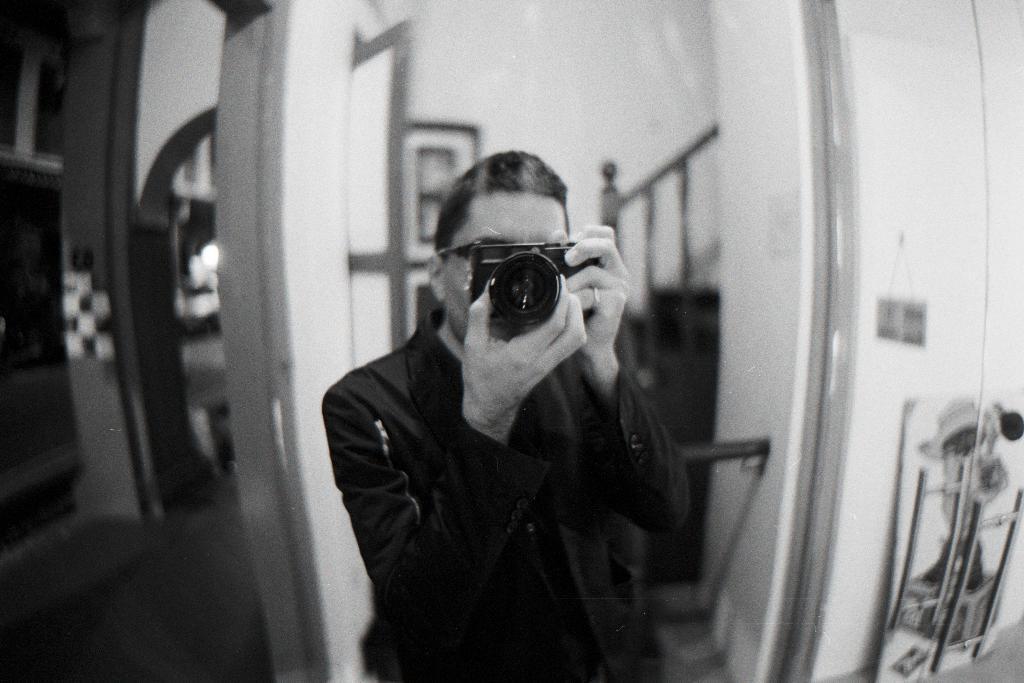Can you describe this image briefly? In this picture there is a man standing here, there is a camera in both of his hands and in the backdrop there is a door and in right there is a staircase. On to the left there is a floor and in the backdrop there is a wall. 